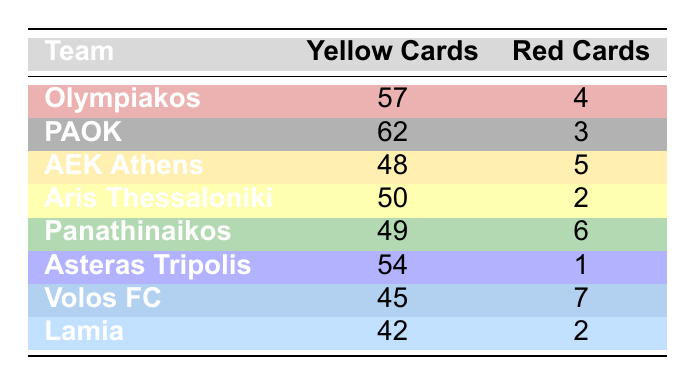What is the total number of yellow cards issued by all teams combined? To find the total number of yellow cards, we add the yellow cards for all teams: 57 (Olympiakos) + 62 (PAOK) + 48 (AEK Athens) + 50 (Aris Thessaloniki) + 49 (Panathinaikos) + 54 (Asteras Tripolis) + 45 (Volos FC) + 42 (Lamia) = 417
Answer: 417 Which team received the highest number of red cards? Looking at the red cards column, Volos FC has the highest count with 7 red cards, compared to the others which have 2 to 6
Answer: Volos FC What is the average number of yellow cards issued by the teams? First, sum the yellow cards: 57 + 62 + 48 + 50 + 49 + 54 + 45 + 42 = 417. Then divide by the number of teams, which is 8: 417/8 = 52.125, rounding gives us 52
Answer: 52 Is it true that AEK Athens received more red cards than Olympiakos? AEK Athens received 5 red cards and Olympiakos received 4 red cards. Since 5 is greater than 4, the statement is true
Answer: Yes Which team has the least number of yellow cards and how many did they receive? Checking the yellow cards, Lamia has the least with 42 yellow cards, compared to other teams which have between 45 and 62
Answer: Lamia, 42 Calculate the difference in the number of yellow cards issued between PAOK and Asteras Tripolis. PAOK has 62 yellow cards and Asteras Tripolis has 54 yellow cards. The difference is 62 - 54 = 8 yellow cards
Answer: 8 Do any teams have the same number of yellow cards? Examining the yellow cards, no teams are tied because the counts of 57, 62, 48, 50, 49, 54, 45, and 42 are all unique
Answer: No Which team had a higher red cards count, Panathinaikos or Aris Thessaloniki? Panathinaikos received 6 red cards while Aris Thessaloniki had only 2. Since 6 is greater than 2, Panathinaikos has the higher count
Answer: Panathinaikos 